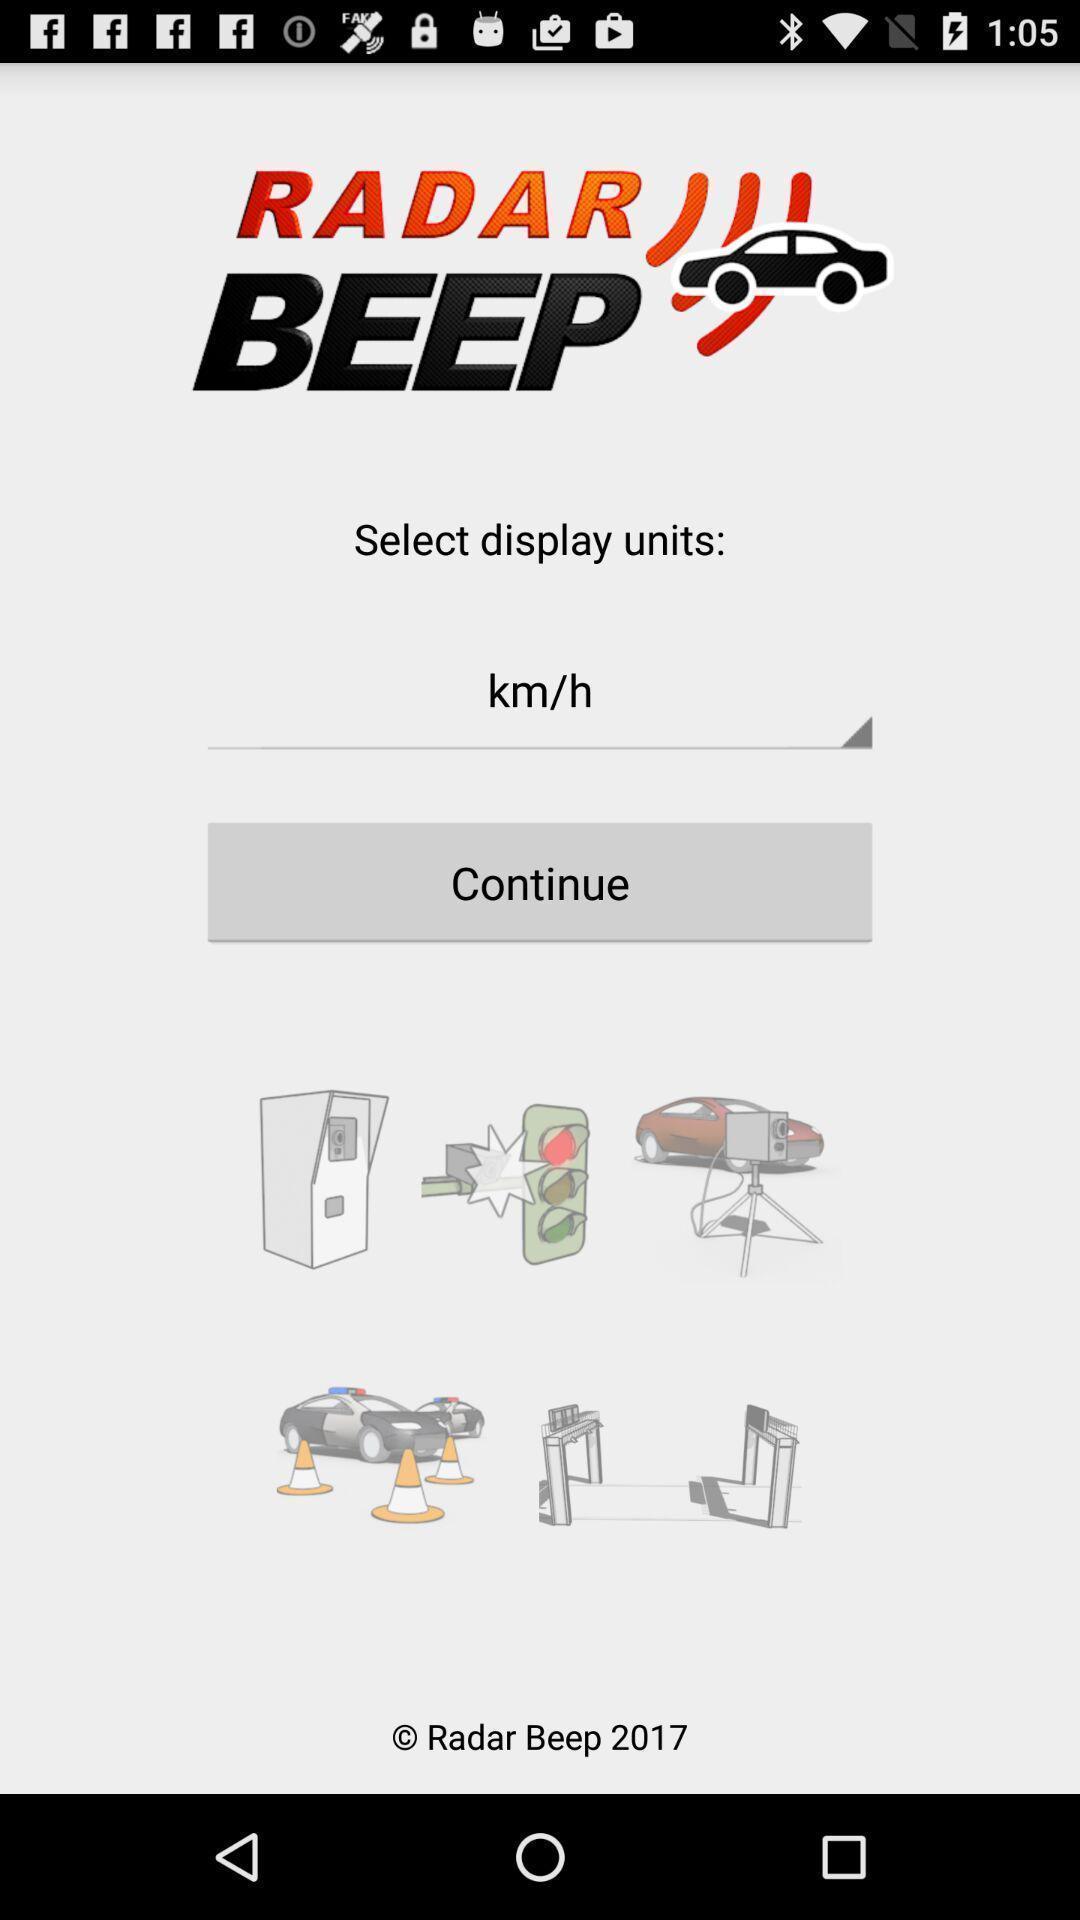Provide a detailed account of this screenshot. Page displaying to select the units. 